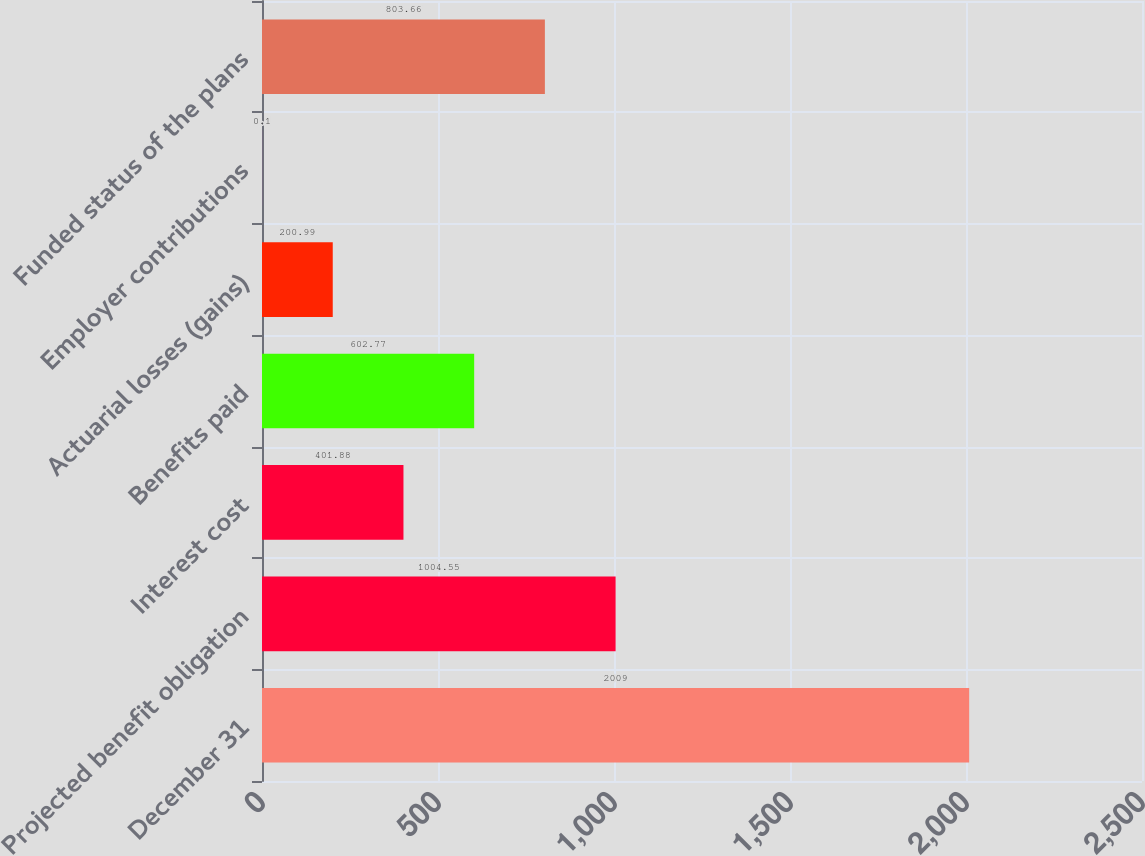Convert chart to OTSL. <chart><loc_0><loc_0><loc_500><loc_500><bar_chart><fcel>December 31<fcel>Projected benefit obligation<fcel>Interest cost<fcel>Benefits paid<fcel>Actuarial losses (gains)<fcel>Employer contributions<fcel>Funded status of the plans<nl><fcel>2009<fcel>1004.55<fcel>401.88<fcel>602.77<fcel>200.99<fcel>0.1<fcel>803.66<nl></chart> 